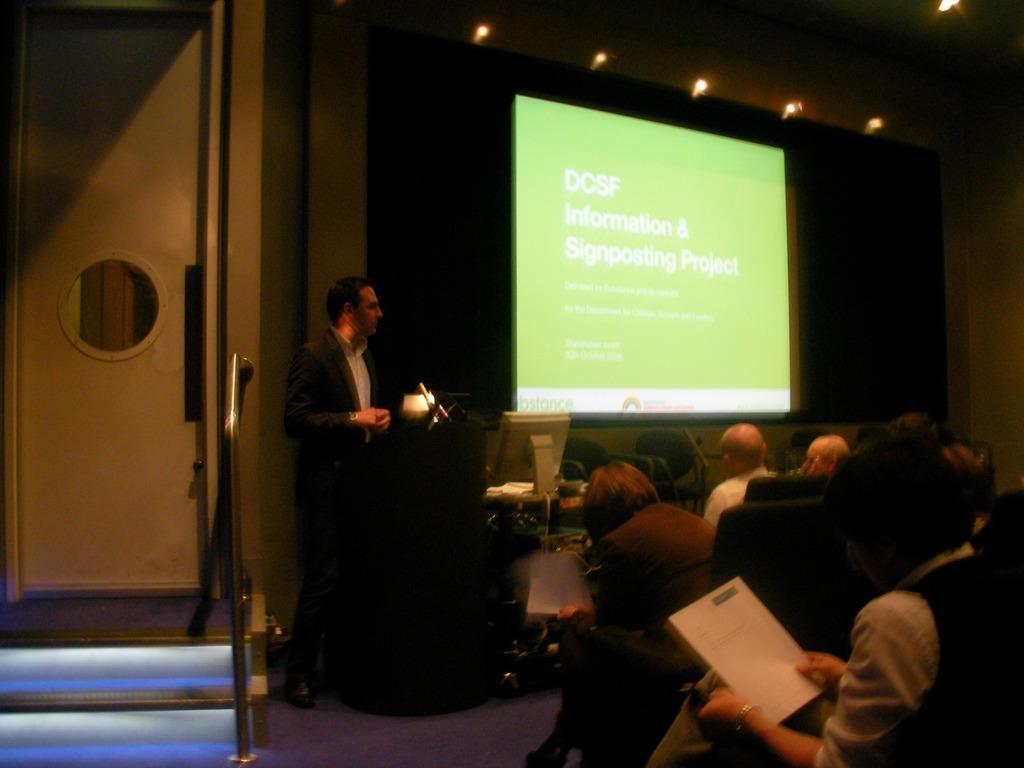Describe this image in one or two sentences. In this picture there are few persons sitting in chairs in the right corner and there is a person standing in front of them and there is a desktop beside him and there is a projected image in the background and there is a door in the left corner. 